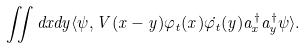Convert formula to latex. <formula><loc_0><loc_0><loc_500><loc_500>\iint d x d y \langle \psi , V ( x - y ) \varphi _ { t } ( x ) \dot { \varphi _ { t } } ( y ) a _ { x } ^ { \dag } a _ { y } ^ { \dag } \psi \rangle .</formula> 